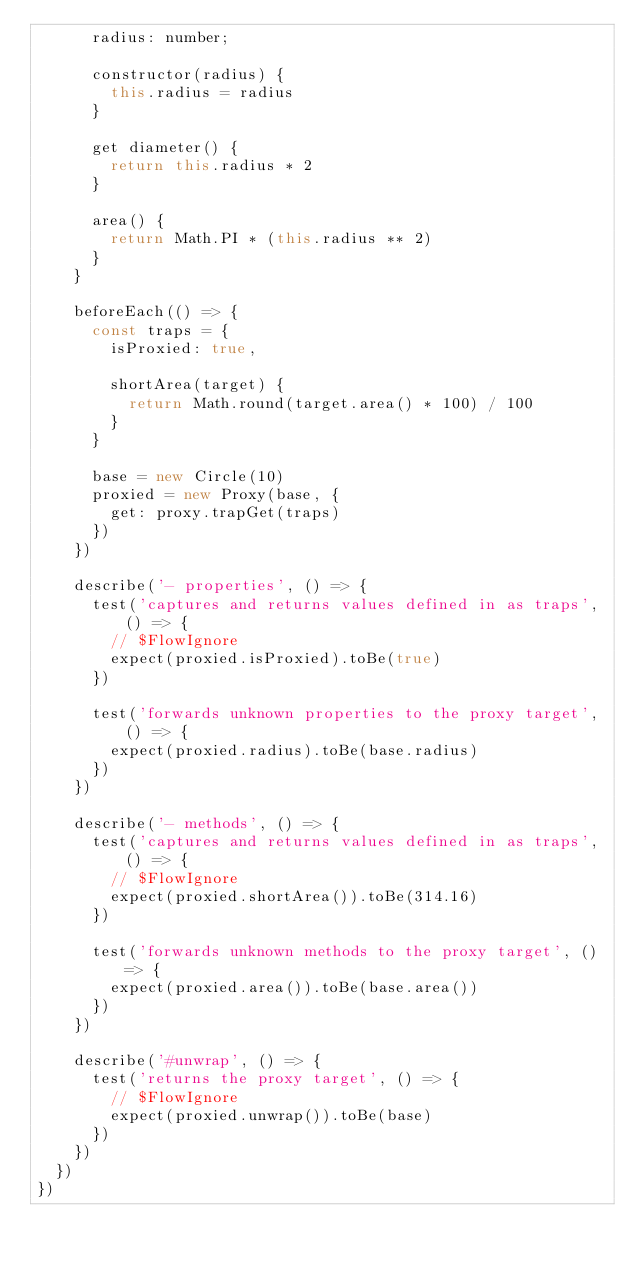<code> <loc_0><loc_0><loc_500><loc_500><_JavaScript_>      radius: number;

      constructor(radius) {
        this.radius = radius
      }

      get diameter() {
        return this.radius * 2
      }

      area() {
        return Math.PI * (this.radius ** 2)
      }
    }

    beforeEach(() => {
      const traps = {
        isProxied: true,

        shortArea(target) {
          return Math.round(target.area() * 100) / 100
        }
      }

      base = new Circle(10)
      proxied = new Proxy(base, {
        get: proxy.trapGet(traps)
      })
    })

    describe('- properties', () => {
      test('captures and returns values defined in as traps', () => {
        // $FlowIgnore
        expect(proxied.isProxied).toBe(true)
      })

      test('forwards unknown properties to the proxy target', () => {
        expect(proxied.radius).toBe(base.radius)
      })
    })

    describe('- methods', () => {
      test('captures and returns values defined in as traps', () => {
        // $FlowIgnore
        expect(proxied.shortArea()).toBe(314.16)
      })

      test('forwards unknown methods to the proxy target', () => {
        expect(proxied.area()).toBe(base.area())
      })
    })

    describe('#unwrap', () => {
      test('returns the proxy target', () => {
        // $FlowIgnore
        expect(proxied.unwrap()).toBe(base)
      })
    })
  })
})
</code> 